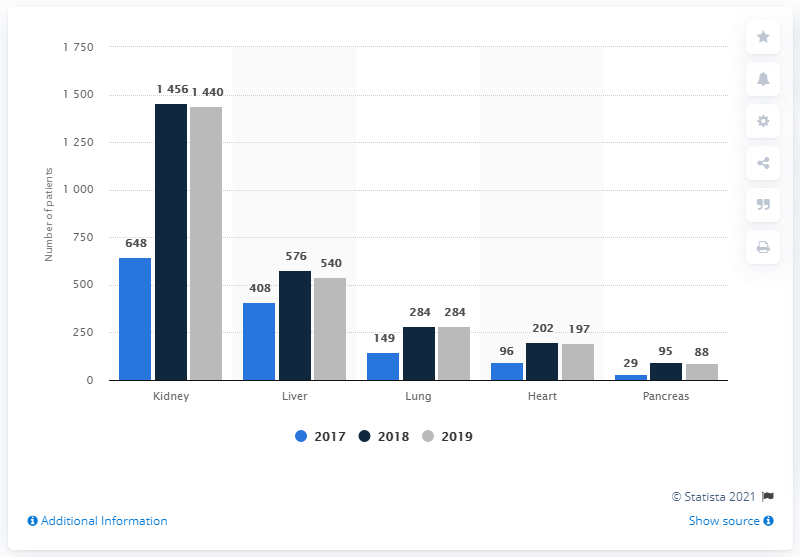Specify some key components in this picture. The difference between the sum of all the patients waiting for kidney transplant over all the years and the sum of people waiting for lung transplant over all the years is 2827. In 2017, there were 648 patients waiting for a kidney transplant. 